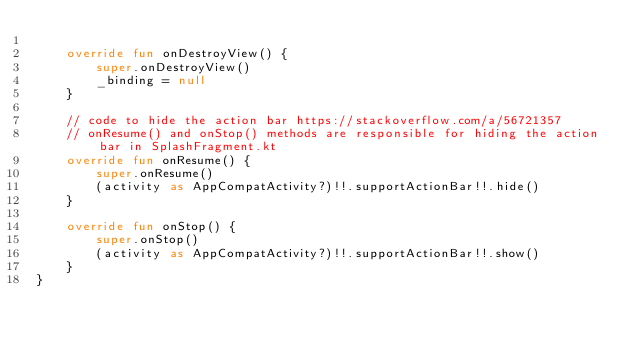Convert code to text. <code><loc_0><loc_0><loc_500><loc_500><_Kotlin_>
    override fun onDestroyView() {
        super.onDestroyView()
        _binding = null
    }

    // code to hide the action bar https://stackoverflow.com/a/56721357
    // onResume() and onStop() methods are responsible for hiding the action bar in SplashFragment.kt
    override fun onResume() {
        super.onResume()
        (activity as AppCompatActivity?)!!.supportActionBar!!.hide()
    }

    override fun onStop() {
        super.onStop()
        (activity as AppCompatActivity?)!!.supportActionBar!!.show()
    }
}</code> 